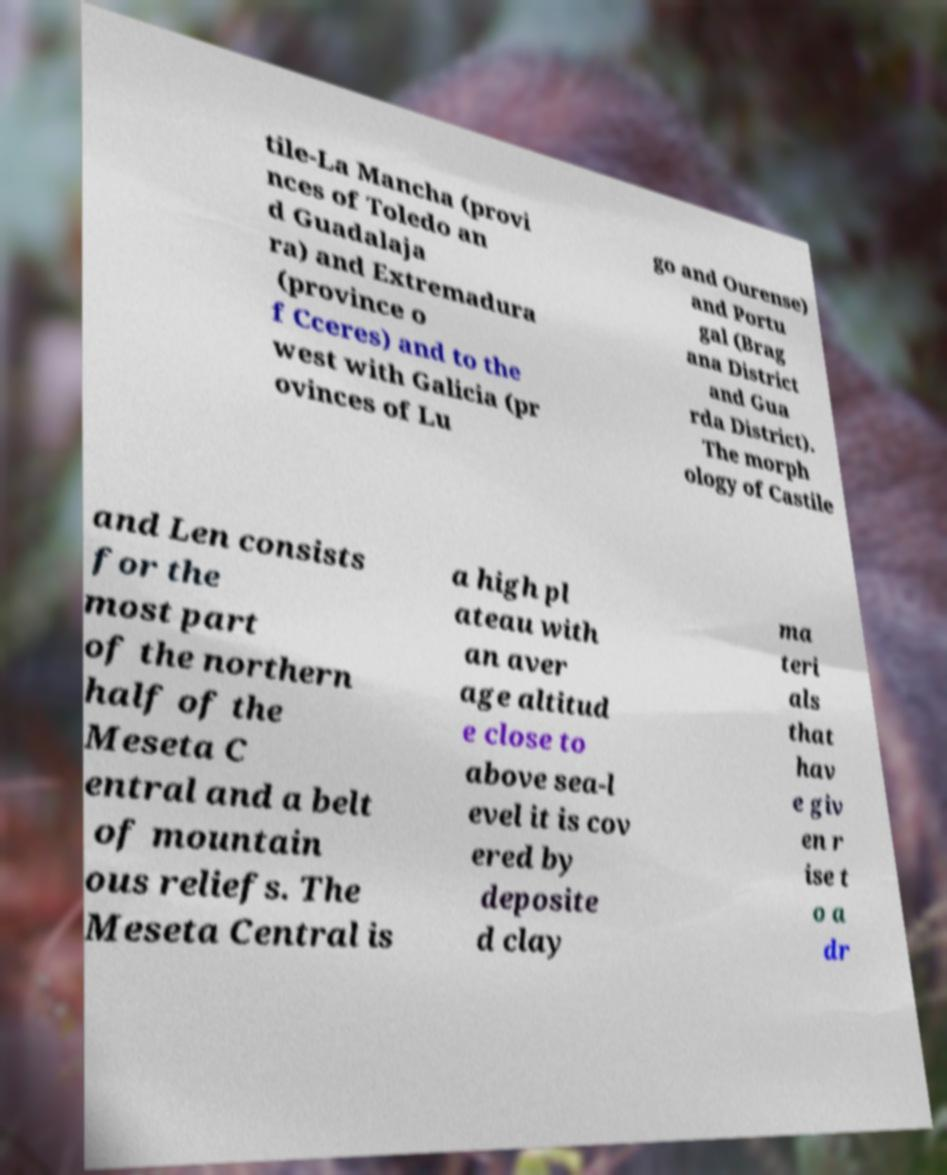Could you extract and type out the text from this image? tile-La Mancha (provi nces of Toledo an d Guadalaja ra) and Extremadura (province o f Cceres) and to the west with Galicia (pr ovinces of Lu go and Ourense) and Portu gal (Brag ana District and Gua rda District). The morph ology of Castile and Len consists for the most part of the northern half of the Meseta C entral and a belt of mountain ous reliefs. The Meseta Central is a high pl ateau with an aver age altitud e close to above sea-l evel it is cov ered by deposite d clay ma teri als that hav e giv en r ise t o a dr 